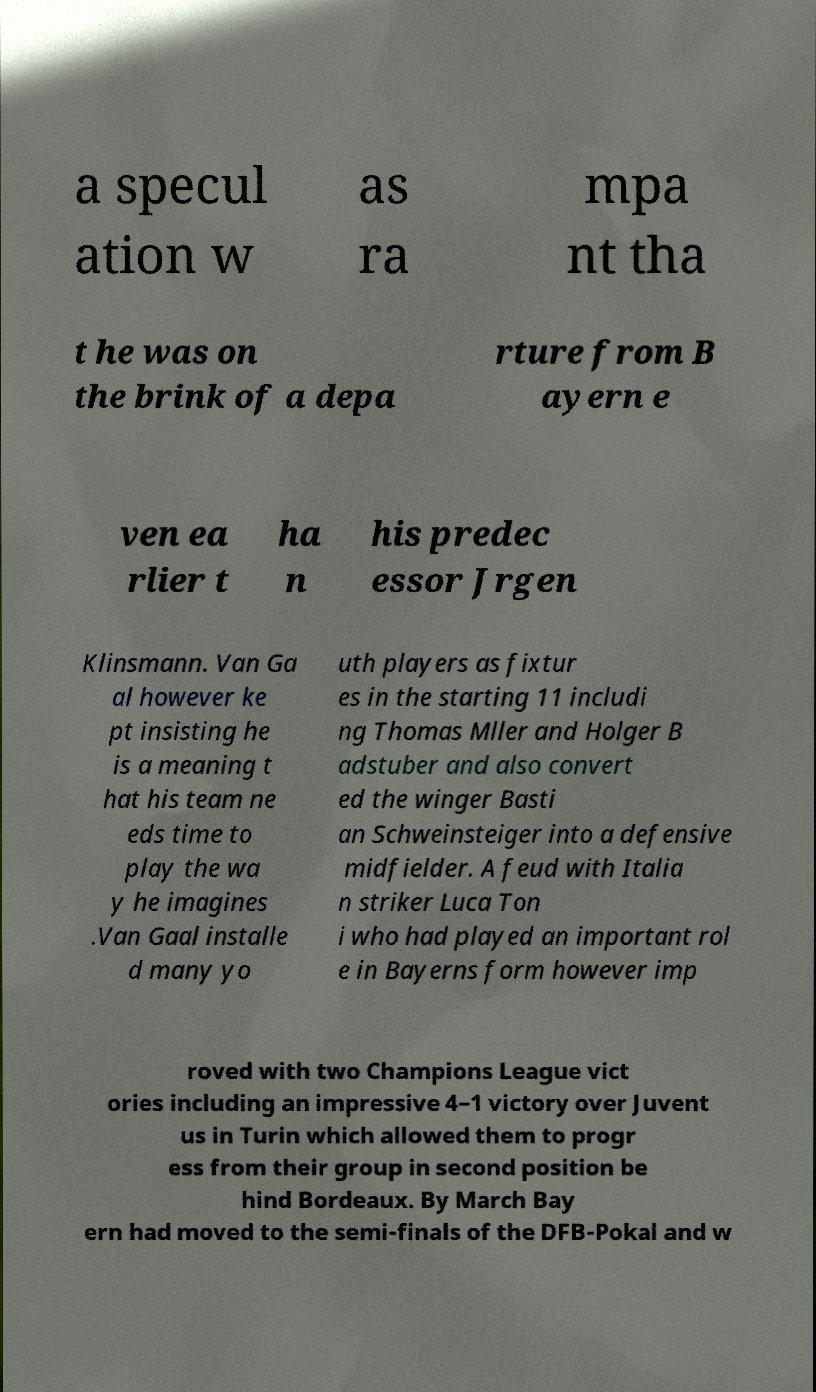Could you assist in decoding the text presented in this image and type it out clearly? a specul ation w as ra mpa nt tha t he was on the brink of a depa rture from B ayern e ven ea rlier t ha n his predec essor Jrgen Klinsmann. Van Ga al however ke pt insisting he is a meaning t hat his team ne eds time to play the wa y he imagines .Van Gaal installe d many yo uth players as fixtur es in the starting 11 includi ng Thomas Mller and Holger B adstuber and also convert ed the winger Basti an Schweinsteiger into a defensive midfielder. A feud with Italia n striker Luca Ton i who had played an important rol e in Bayerns form however imp roved with two Champions League vict ories including an impressive 4–1 victory over Juvent us in Turin which allowed them to progr ess from their group in second position be hind Bordeaux. By March Bay ern had moved to the semi-finals of the DFB-Pokal and w 